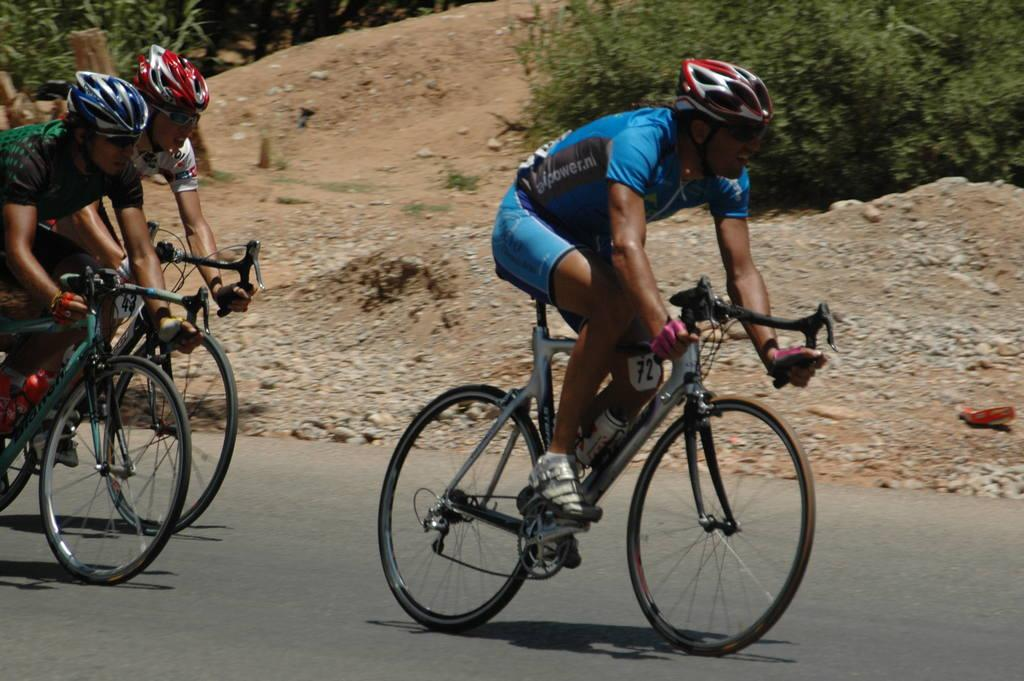How many people are in the image? There are three persons in the image. What are the persons wearing on their heads? The persons are wearing helmets. What activity are the persons engaged in? The persons are cycling on the road. Can you describe the clothing of the persons? The persons are wearing different color dresses. What can be seen in the background of the image? There are stones and plants on a hill in the background of the image. What time of day is it in the image, based on the hour? The provided facts do not mention the time of day or any specific hour, so it cannot be determined from the image. What type of paste is being used by the persons in the image? There is no paste visible or mentioned in the image. 